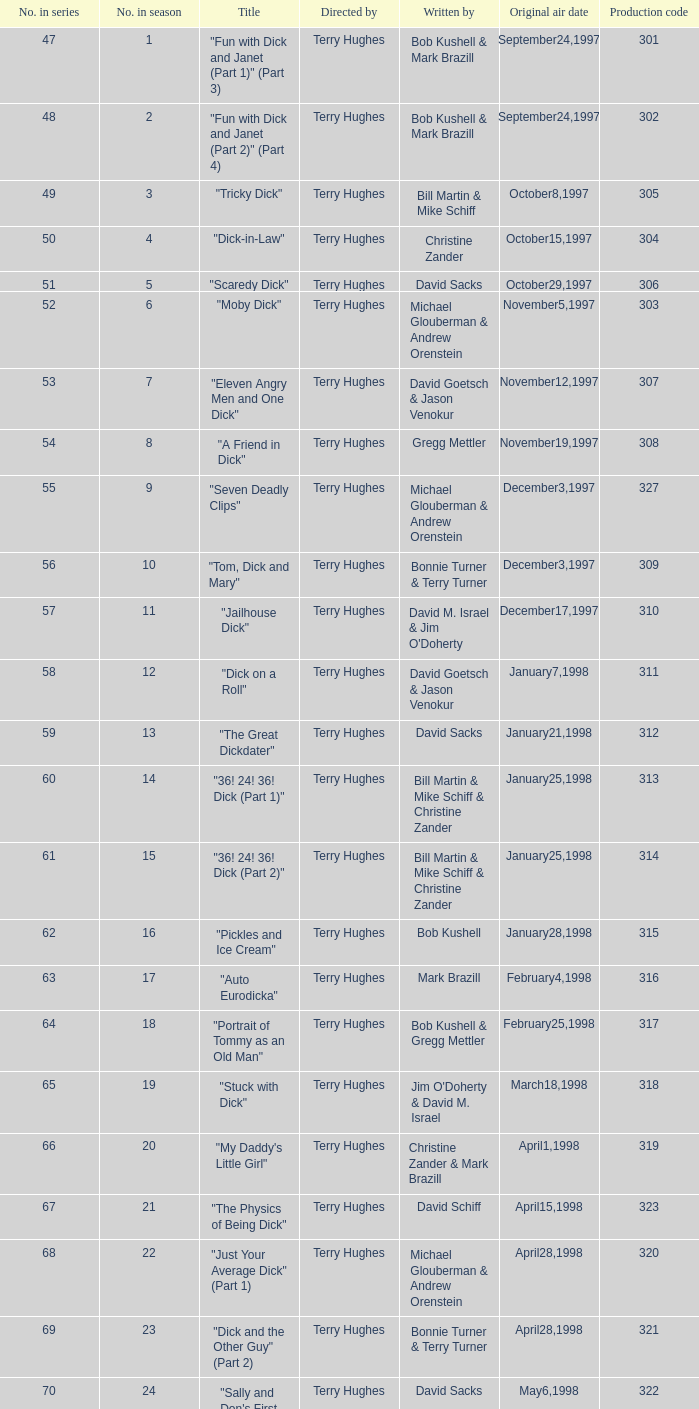What is the title of episode 10? "Tom, Dick and Mary". 